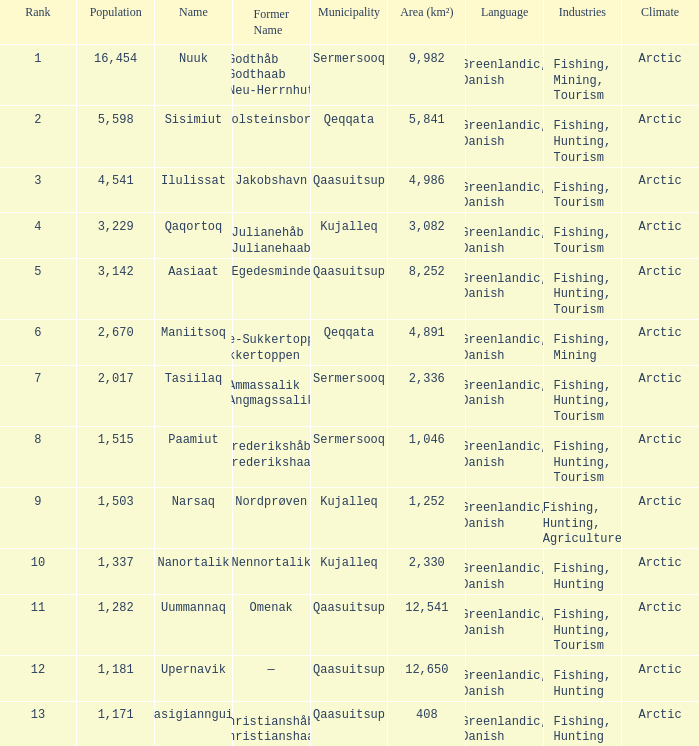What is the population for Rank 11? 1282.0. 